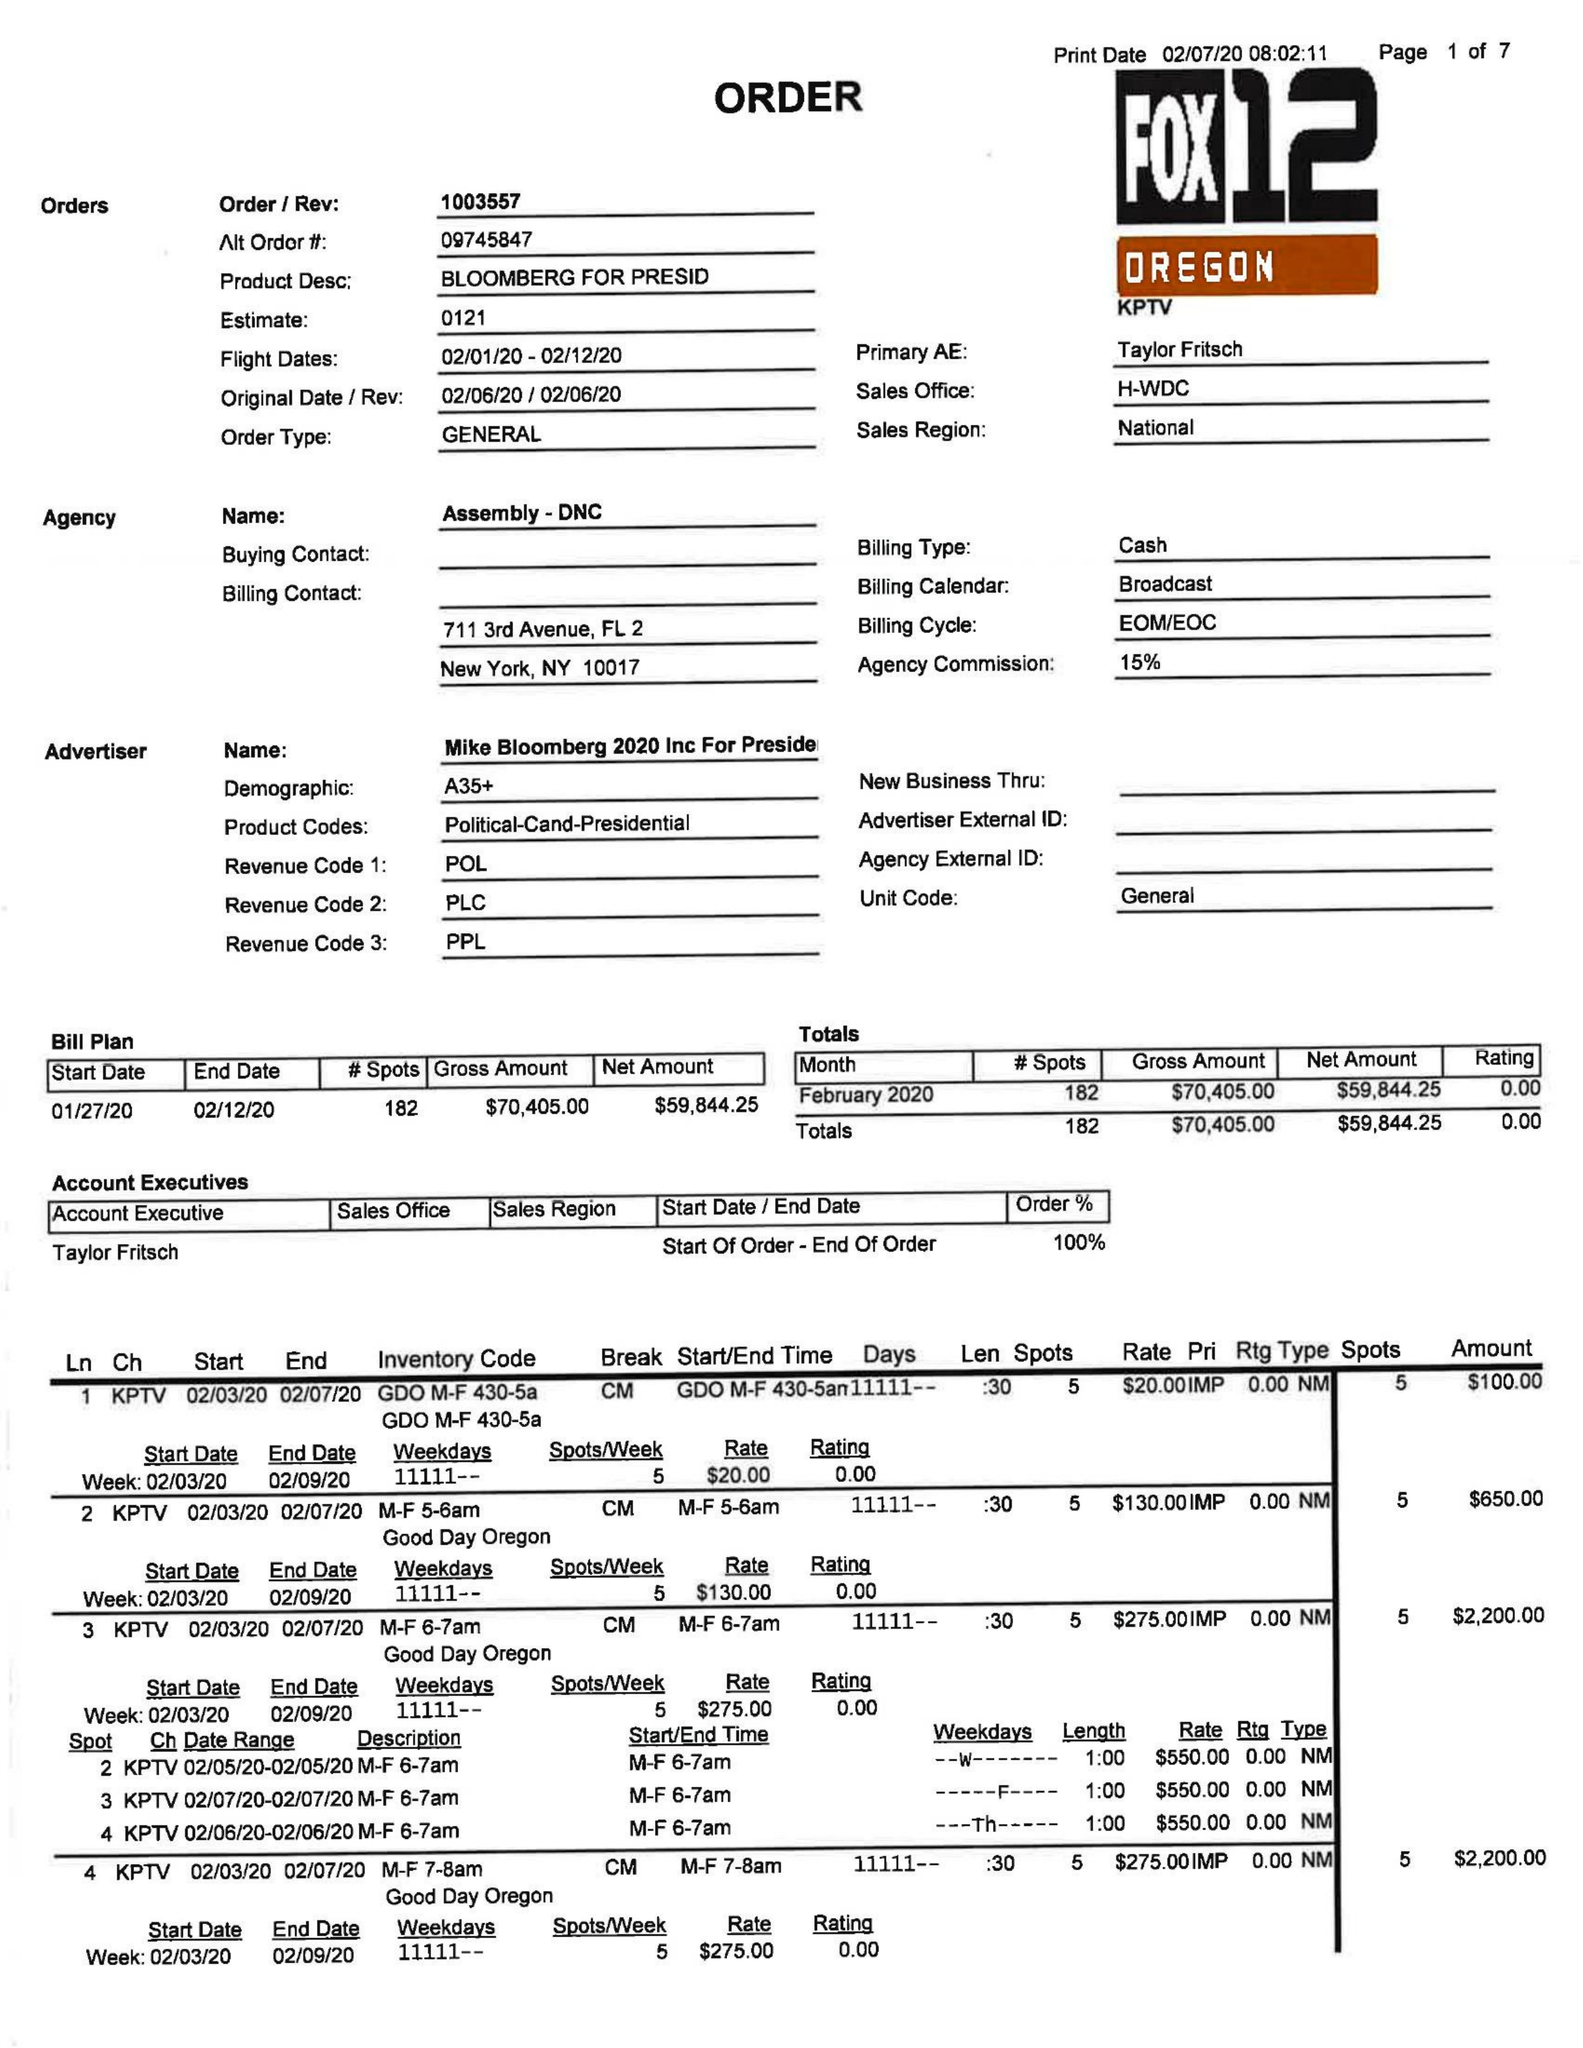What is the value for the advertiser?
Answer the question using a single word or phrase. MIKE BLOOMBERG 2020 INC FOR PRESIDENT 